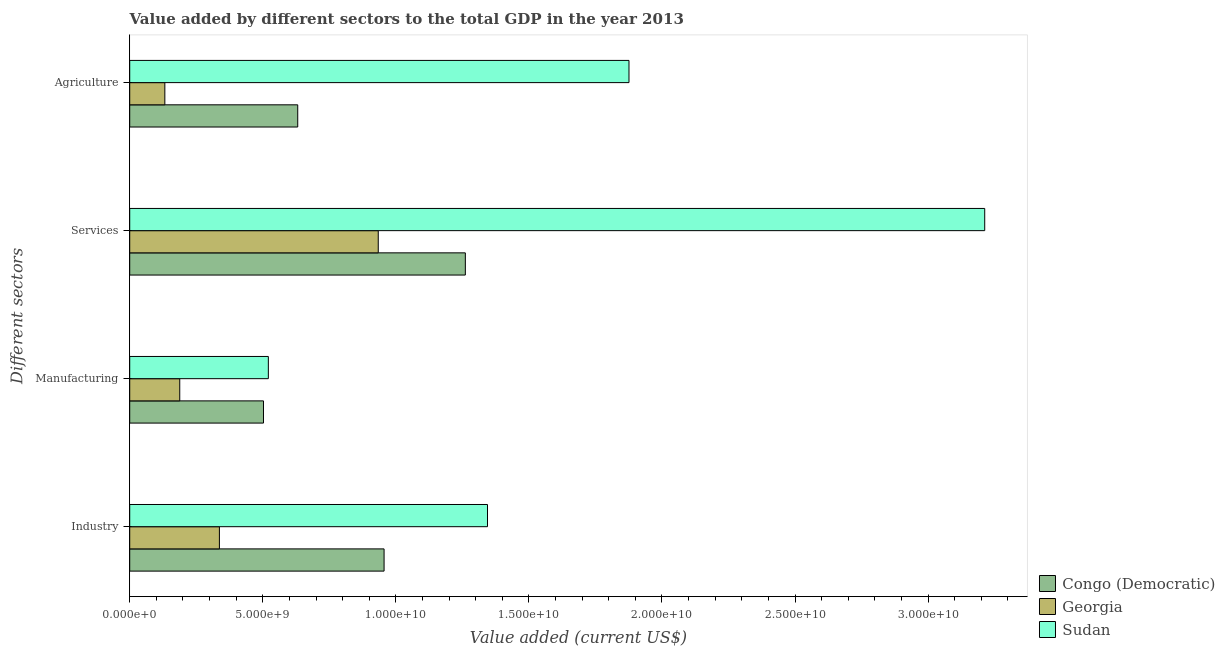How many different coloured bars are there?
Your answer should be very brief. 3. How many groups of bars are there?
Ensure brevity in your answer.  4. How many bars are there on the 4th tick from the top?
Make the answer very short. 3. What is the label of the 4th group of bars from the top?
Ensure brevity in your answer.  Industry. What is the value added by industrial sector in Congo (Democratic)?
Offer a very short reply. 9.56e+09. Across all countries, what is the maximum value added by industrial sector?
Keep it short and to the point. 1.34e+1. Across all countries, what is the minimum value added by agricultural sector?
Keep it short and to the point. 1.32e+09. In which country was the value added by services sector maximum?
Ensure brevity in your answer.  Sudan. In which country was the value added by agricultural sector minimum?
Keep it short and to the point. Georgia. What is the total value added by manufacturing sector in the graph?
Your answer should be compact. 1.21e+1. What is the difference between the value added by industrial sector in Georgia and that in Congo (Democratic)?
Your answer should be compact. -6.19e+09. What is the difference between the value added by manufacturing sector in Congo (Democratic) and the value added by agricultural sector in Sudan?
Ensure brevity in your answer.  -1.37e+1. What is the average value added by agricultural sector per country?
Provide a succinct answer. 8.80e+09. What is the difference between the value added by agricultural sector and value added by manufacturing sector in Georgia?
Make the answer very short. -5.60e+08. In how many countries, is the value added by agricultural sector greater than 5000000000 US$?
Provide a short and direct response. 2. What is the ratio of the value added by services sector in Sudan to that in Congo (Democratic)?
Your answer should be compact. 2.55. What is the difference between the highest and the second highest value added by manufacturing sector?
Your answer should be compact. 1.82e+08. What is the difference between the highest and the lowest value added by manufacturing sector?
Give a very brief answer. 3.33e+09. In how many countries, is the value added by services sector greater than the average value added by services sector taken over all countries?
Keep it short and to the point. 1. What does the 1st bar from the top in Manufacturing represents?
Provide a short and direct response. Sudan. What does the 3rd bar from the bottom in Services represents?
Make the answer very short. Sudan. Is it the case that in every country, the sum of the value added by industrial sector and value added by manufacturing sector is greater than the value added by services sector?
Keep it short and to the point. No. Are all the bars in the graph horizontal?
Provide a succinct answer. Yes. How many countries are there in the graph?
Give a very brief answer. 3. How many legend labels are there?
Your response must be concise. 3. What is the title of the graph?
Keep it short and to the point. Value added by different sectors to the total GDP in the year 2013. Does "Isle of Man" appear as one of the legend labels in the graph?
Provide a short and direct response. No. What is the label or title of the X-axis?
Your answer should be compact. Value added (current US$). What is the label or title of the Y-axis?
Keep it short and to the point. Different sectors. What is the Value added (current US$) of Congo (Democratic) in Industry?
Offer a terse response. 9.56e+09. What is the Value added (current US$) of Georgia in Industry?
Provide a succinct answer. 3.37e+09. What is the Value added (current US$) of Sudan in Industry?
Offer a terse response. 1.34e+1. What is the Value added (current US$) of Congo (Democratic) in Manufacturing?
Provide a short and direct response. 5.03e+09. What is the Value added (current US$) in Georgia in Manufacturing?
Ensure brevity in your answer.  1.88e+09. What is the Value added (current US$) in Sudan in Manufacturing?
Keep it short and to the point. 5.21e+09. What is the Value added (current US$) of Congo (Democratic) in Services?
Make the answer very short. 1.26e+1. What is the Value added (current US$) in Georgia in Services?
Your answer should be compact. 9.34e+09. What is the Value added (current US$) of Sudan in Services?
Keep it short and to the point. 3.21e+1. What is the Value added (current US$) of Congo (Democratic) in Agriculture?
Your response must be concise. 6.31e+09. What is the Value added (current US$) in Georgia in Agriculture?
Offer a very short reply. 1.32e+09. What is the Value added (current US$) of Sudan in Agriculture?
Provide a short and direct response. 1.88e+1. Across all Different sectors, what is the maximum Value added (current US$) of Congo (Democratic)?
Keep it short and to the point. 1.26e+1. Across all Different sectors, what is the maximum Value added (current US$) of Georgia?
Offer a very short reply. 9.34e+09. Across all Different sectors, what is the maximum Value added (current US$) of Sudan?
Keep it short and to the point. 3.21e+1. Across all Different sectors, what is the minimum Value added (current US$) in Congo (Democratic)?
Give a very brief answer. 5.03e+09. Across all Different sectors, what is the minimum Value added (current US$) in Georgia?
Ensure brevity in your answer.  1.32e+09. Across all Different sectors, what is the minimum Value added (current US$) in Sudan?
Your answer should be very brief. 5.21e+09. What is the total Value added (current US$) of Congo (Democratic) in the graph?
Ensure brevity in your answer.  3.35e+1. What is the total Value added (current US$) in Georgia in the graph?
Make the answer very short. 1.59e+1. What is the total Value added (current US$) in Sudan in the graph?
Give a very brief answer. 6.95e+1. What is the difference between the Value added (current US$) in Congo (Democratic) in Industry and that in Manufacturing?
Offer a terse response. 4.53e+09. What is the difference between the Value added (current US$) of Georgia in Industry and that in Manufacturing?
Offer a very short reply. 1.49e+09. What is the difference between the Value added (current US$) in Sudan in Industry and that in Manufacturing?
Ensure brevity in your answer.  8.24e+09. What is the difference between the Value added (current US$) in Congo (Democratic) in Industry and that in Services?
Your response must be concise. -3.05e+09. What is the difference between the Value added (current US$) in Georgia in Industry and that in Services?
Your response must be concise. -5.97e+09. What is the difference between the Value added (current US$) in Sudan in Industry and that in Services?
Keep it short and to the point. -1.87e+1. What is the difference between the Value added (current US$) in Congo (Democratic) in Industry and that in Agriculture?
Ensure brevity in your answer.  3.24e+09. What is the difference between the Value added (current US$) in Georgia in Industry and that in Agriculture?
Ensure brevity in your answer.  2.05e+09. What is the difference between the Value added (current US$) in Sudan in Industry and that in Agriculture?
Offer a very short reply. -5.32e+09. What is the difference between the Value added (current US$) in Congo (Democratic) in Manufacturing and that in Services?
Your answer should be very brief. -7.59e+09. What is the difference between the Value added (current US$) of Georgia in Manufacturing and that in Services?
Your answer should be very brief. -7.46e+09. What is the difference between the Value added (current US$) in Sudan in Manufacturing and that in Services?
Your answer should be compact. -2.69e+1. What is the difference between the Value added (current US$) in Congo (Democratic) in Manufacturing and that in Agriculture?
Provide a succinct answer. -1.29e+09. What is the difference between the Value added (current US$) in Georgia in Manufacturing and that in Agriculture?
Keep it short and to the point. 5.60e+08. What is the difference between the Value added (current US$) of Sudan in Manufacturing and that in Agriculture?
Make the answer very short. -1.36e+1. What is the difference between the Value added (current US$) in Congo (Democratic) in Services and that in Agriculture?
Give a very brief answer. 6.30e+09. What is the difference between the Value added (current US$) in Georgia in Services and that in Agriculture?
Give a very brief answer. 8.02e+09. What is the difference between the Value added (current US$) of Sudan in Services and that in Agriculture?
Keep it short and to the point. 1.34e+1. What is the difference between the Value added (current US$) in Congo (Democratic) in Industry and the Value added (current US$) in Georgia in Manufacturing?
Your response must be concise. 7.68e+09. What is the difference between the Value added (current US$) in Congo (Democratic) in Industry and the Value added (current US$) in Sudan in Manufacturing?
Your response must be concise. 4.35e+09. What is the difference between the Value added (current US$) in Georgia in Industry and the Value added (current US$) in Sudan in Manufacturing?
Offer a very short reply. -1.84e+09. What is the difference between the Value added (current US$) in Congo (Democratic) in Industry and the Value added (current US$) in Georgia in Services?
Make the answer very short. 2.19e+08. What is the difference between the Value added (current US$) of Congo (Democratic) in Industry and the Value added (current US$) of Sudan in Services?
Provide a short and direct response. -2.26e+1. What is the difference between the Value added (current US$) in Georgia in Industry and the Value added (current US$) in Sudan in Services?
Your response must be concise. -2.88e+1. What is the difference between the Value added (current US$) in Congo (Democratic) in Industry and the Value added (current US$) in Georgia in Agriculture?
Ensure brevity in your answer.  8.24e+09. What is the difference between the Value added (current US$) in Congo (Democratic) in Industry and the Value added (current US$) in Sudan in Agriculture?
Provide a succinct answer. -9.20e+09. What is the difference between the Value added (current US$) in Georgia in Industry and the Value added (current US$) in Sudan in Agriculture?
Offer a very short reply. -1.54e+1. What is the difference between the Value added (current US$) in Congo (Democratic) in Manufacturing and the Value added (current US$) in Georgia in Services?
Provide a succinct answer. -4.31e+09. What is the difference between the Value added (current US$) in Congo (Democratic) in Manufacturing and the Value added (current US$) in Sudan in Services?
Offer a very short reply. -2.71e+1. What is the difference between the Value added (current US$) in Georgia in Manufacturing and the Value added (current US$) in Sudan in Services?
Ensure brevity in your answer.  -3.02e+1. What is the difference between the Value added (current US$) of Congo (Democratic) in Manufacturing and the Value added (current US$) of Georgia in Agriculture?
Your answer should be compact. 3.71e+09. What is the difference between the Value added (current US$) in Congo (Democratic) in Manufacturing and the Value added (current US$) in Sudan in Agriculture?
Give a very brief answer. -1.37e+1. What is the difference between the Value added (current US$) in Georgia in Manufacturing and the Value added (current US$) in Sudan in Agriculture?
Your answer should be compact. -1.69e+1. What is the difference between the Value added (current US$) in Congo (Democratic) in Services and the Value added (current US$) in Georgia in Agriculture?
Offer a terse response. 1.13e+1. What is the difference between the Value added (current US$) in Congo (Democratic) in Services and the Value added (current US$) in Sudan in Agriculture?
Offer a terse response. -6.15e+09. What is the difference between the Value added (current US$) in Georgia in Services and the Value added (current US$) in Sudan in Agriculture?
Provide a short and direct response. -9.42e+09. What is the average Value added (current US$) in Congo (Democratic) per Different sectors?
Your response must be concise. 8.38e+09. What is the average Value added (current US$) in Georgia per Different sectors?
Give a very brief answer. 3.98e+09. What is the average Value added (current US$) of Sudan per Different sectors?
Provide a succinct answer. 1.74e+1. What is the difference between the Value added (current US$) in Congo (Democratic) and Value added (current US$) in Georgia in Industry?
Make the answer very short. 6.19e+09. What is the difference between the Value added (current US$) of Congo (Democratic) and Value added (current US$) of Sudan in Industry?
Offer a very short reply. -3.89e+09. What is the difference between the Value added (current US$) of Georgia and Value added (current US$) of Sudan in Industry?
Offer a very short reply. -1.01e+1. What is the difference between the Value added (current US$) in Congo (Democratic) and Value added (current US$) in Georgia in Manufacturing?
Provide a succinct answer. 3.15e+09. What is the difference between the Value added (current US$) of Congo (Democratic) and Value added (current US$) of Sudan in Manufacturing?
Your response must be concise. -1.82e+08. What is the difference between the Value added (current US$) of Georgia and Value added (current US$) of Sudan in Manufacturing?
Give a very brief answer. -3.33e+09. What is the difference between the Value added (current US$) of Congo (Democratic) and Value added (current US$) of Georgia in Services?
Provide a short and direct response. 3.27e+09. What is the difference between the Value added (current US$) in Congo (Democratic) and Value added (current US$) in Sudan in Services?
Make the answer very short. -1.95e+1. What is the difference between the Value added (current US$) in Georgia and Value added (current US$) in Sudan in Services?
Your answer should be compact. -2.28e+1. What is the difference between the Value added (current US$) in Congo (Democratic) and Value added (current US$) in Georgia in Agriculture?
Keep it short and to the point. 4.99e+09. What is the difference between the Value added (current US$) of Congo (Democratic) and Value added (current US$) of Sudan in Agriculture?
Give a very brief answer. -1.24e+1. What is the difference between the Value added (current US$) in Georgia and Value added (current US$) in Sudan in Agriculture?
Provide a succinct answer. -1.74e+1. What is the ratio of the Value added (current US$) of Congo (Democratic) in Industry to that in Manufacturing?
Offer a very short reply. 1.9. What is the ratio of the Value added (current US$) in Georgia in Industry to that in Manufacturing?
Your answer should be compact. 1.79. What is the ratio of the Value added (current US$) of Sudan in Industry to that in Manufacturing?
Offer a very short reply. 2.58. What is the ratio of the Value added (current US$) in Congo (Democratic) in Industry to that in Services?
Ensure brevity in your answer.  0.76. What is the ratio of the Value added (current US$) in Georgia in Industry to that in Services?
Provide a succinct answer. 0.36. What is the ratio of the Value added (current US$) in Sudan in Industry to that in Services?
Ensure brevity in your answer.  0.42. What is the ratio of the Value added (current US$) of Congo (Democratic) in Industry to that in Agriculture?
Your response must be concise. 1.51. What is the ratio of the Value added (current US$) in Georgia in Industry to that in Agriculture?
Your answer should be compact. 2.55. What is the ratio of the Value added (current US$) in Sudan in Industry to that in Agriculture?
Your answer should be compact. 0.72. What is the ratio of the Value added (current US$) in Congo (Democratic) in Manufacturing to that in Services?
Offer a terse response. 0.4. What is the ratio of the Value added (current US$) in Georgia in Manufacturing to that in Services?
Your answer should be very brief. 0.2. What is the ratio of the Value added (current US$) in Sudan in Manufacturing to that in Services?
Your response must be concise. 0.16. What is the ratio of the Value added (current US$) in Congo (Democratic) in Manufacturing to that in Agriculture?
Ensure brevity in your answer.  0.8. What is the ratio of the Value added (current US$) in Georgia in Manufacturing to that in Agriculture?
Keep it short and to the point. 1.42. What is the ratio of the Value added (current US$) in Sudan in Manufacturing to that in Agriculture?
Your answer should be very brief. 0.28. What is the ratio of the Value added (current US$) in Congo (Democratic) in Services to that in Agriculture?
Make the answer very short. 2. What is the ratio of the Value added (current US$) in Georgia in Services to that in Agriculture?
Make the answer very short. 7.08. What is the ratio of the Value added (current US$) in Sudan in Services to that in Agriculture?
Your answer should be very brief. 1.71. What is the difference between the highest and the second highest Value added (current US$) in Congo (Democratic)?
Give a very brief answer. 3.05e+09. What is the difference between the highest and the second highest Value added (current US$) in Georgia?
Make the answer very short. 5.97e+09. What is the difference between the highest and the second highest Value added (current US$) of Sudan?
Offer a very short reply. 1.34e+1. What is the difference between the highest and the lowest Value added (current US$) in Congo (Democratic)?
Keep it short and to the point. 7.59e+09. What is the difference between the highest and the lowest Value added (current US$) in Georgia?
Keep it short and to the point. 8.02e+09. What is the difference between the highest and the lowest Value added (current US$) in Sudan?
Provide a succinct answer. 2.69e+1. 